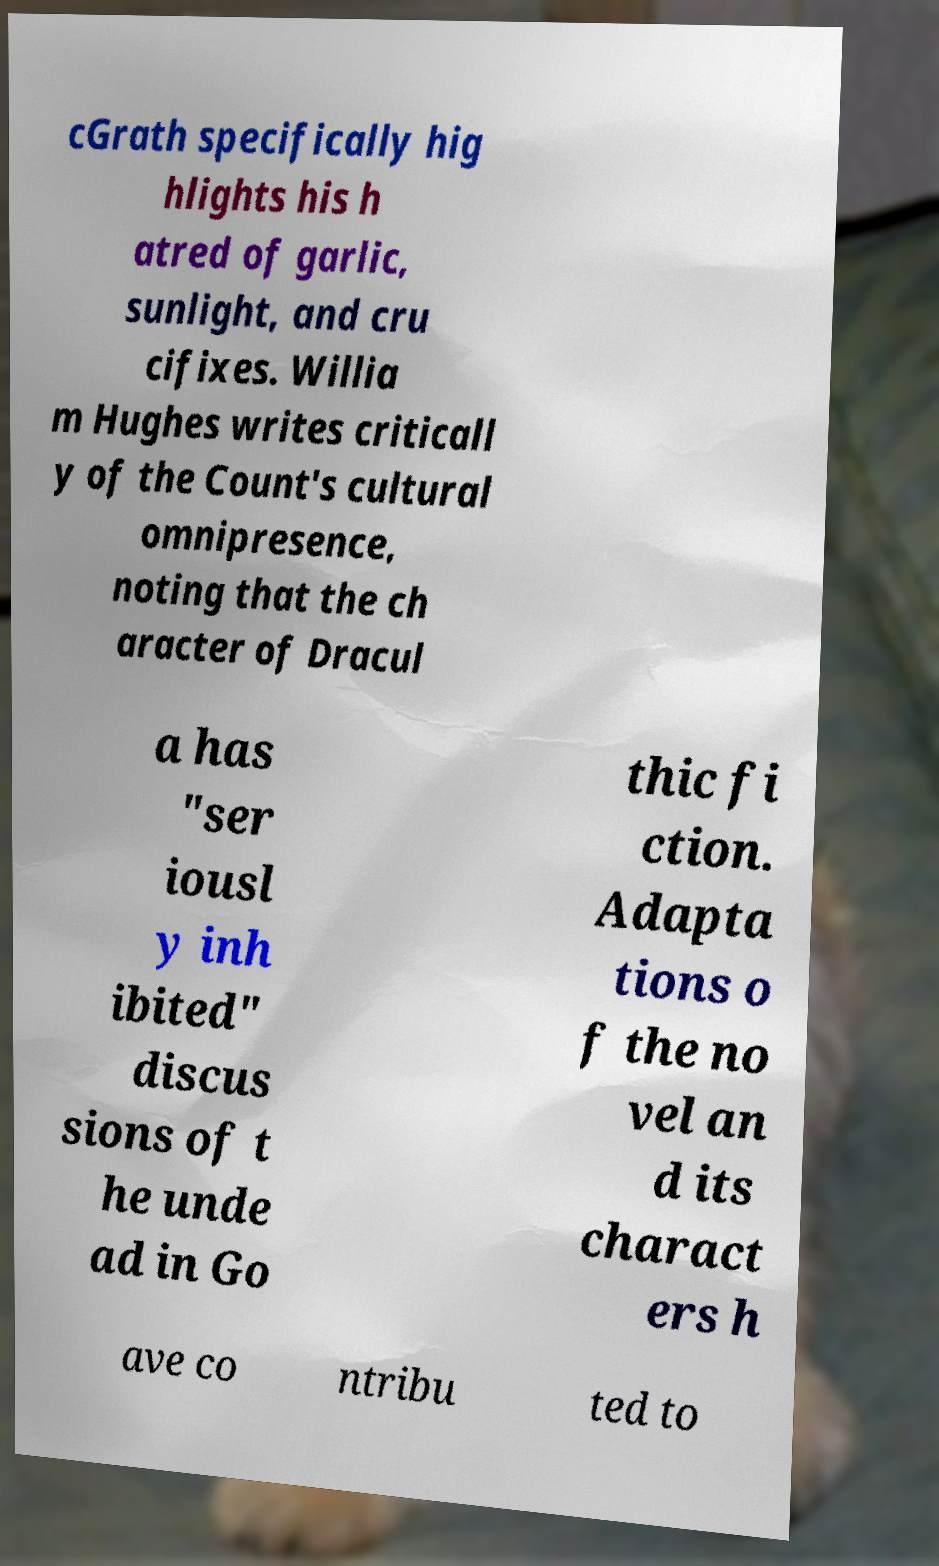Can you accurately transcribe the text from the provided image for me? cGrath specifically hig hlights his h atred of garlic, sunlight, and cru cifixes. Willia m Hughes writes criticall y of the Count's cultural omnipresence, noting that the ch aracter of Dracul a has "ser iousl y inh ibited" discus sions of t he unde ad in Go thic fi ction. Adapta tions o f the no vel an d its charact ers h ave co ntribu ted to 